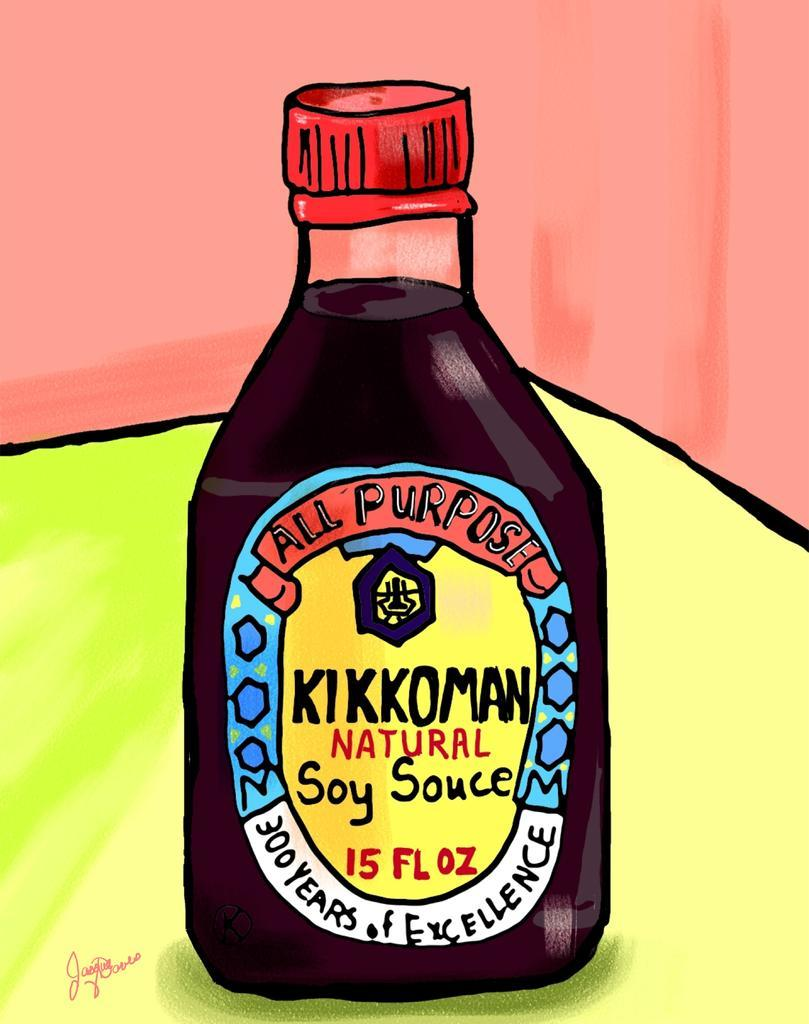<image>
Provide a brief description of the given image. A 15-oz bottle of Kikkoman Soy Sauce sits on a table in a room with pink walls. 